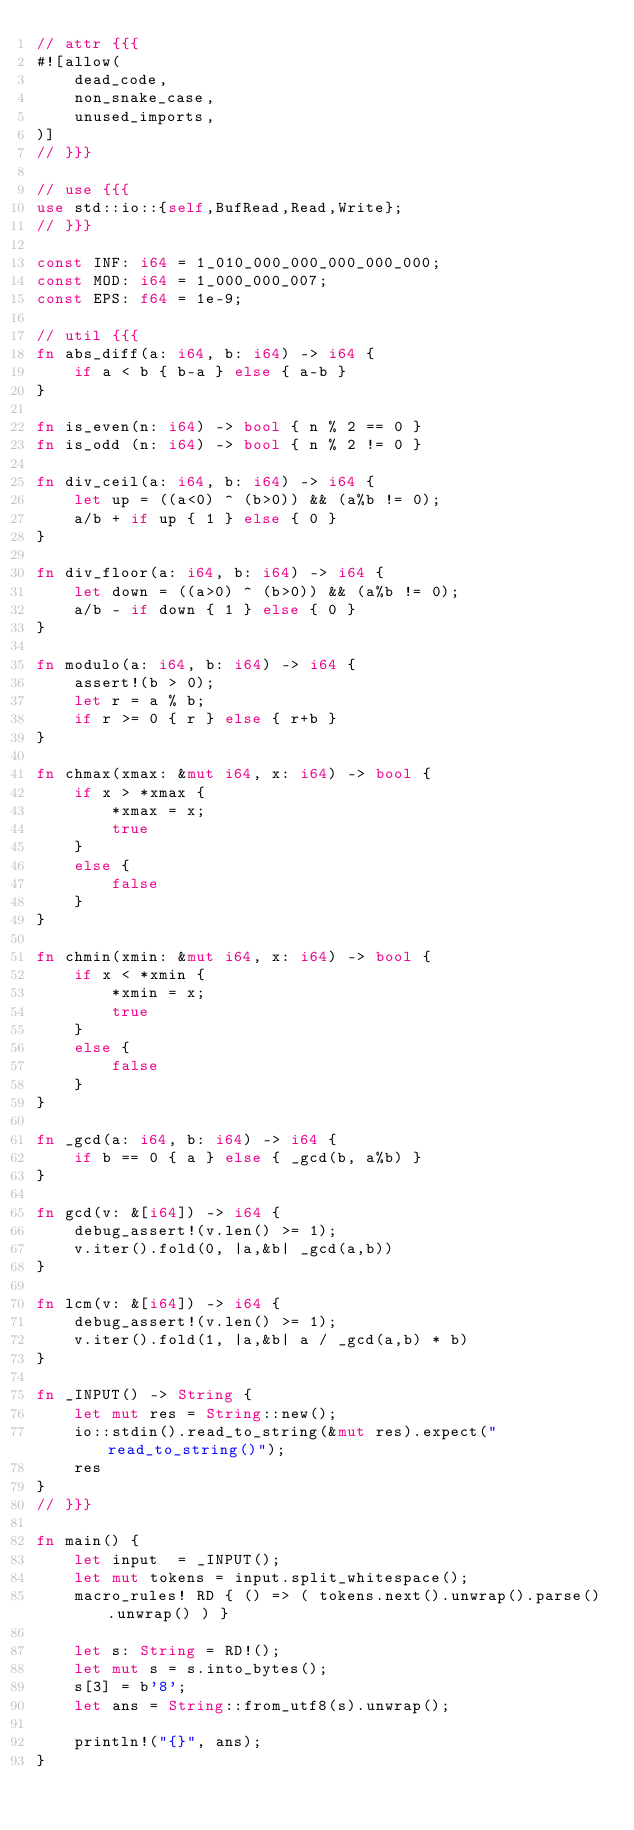Convert code to text. <code><loc_0><loc_0><loc_500><loc_500><_Rust_>// attr {{{
#![allow(
    dead_code,
    non_snake_case,
    unused_imports,
)]
// }}}

// use {{{
use std::io::{self,BufRead,Read,Write};
// }}}

const INF: i64 = 1_010_000_000_000_000_000;
const MOD: i64 = 1_000_000_007;
const EPS: f64 = 1e-9;

// util {{{
fn abs_diff(a: i64, b: i64) -> i64 {
    if a < b { b-a } else { a-b }
}

fn is_even(n: i64) -> bool { n % 2 == 0 }
fn is_odd (n: i64) -> bool { n % 2 != 0 }

fn div_ceil(a: i64, b: i64) -> i64 {
    let up = ((a<0) ^ (b>0)) && (a%b != 0);
    a/b + if up { 1 } else { 0 }
}

fn div_floor(a: i64, b: i64) -> i64 {
    let down = ((a>0) ^ (b>0)) && (a%b != 0);
    a/b - if down { 1 } else { 0 }
}

fn modulo(a: i64, b: i64) -> i64 {
    assert!(b > 0);
    let r = a % b;
    if r >= 0 { r } else { r+b }
}

fn chmax(xmax: &mut i64, x: i64) -> bool {
    if x > *xmax {
        *xmax = x;
        true
    }
    else {
        false
    }
}

fn chmin(xmin: &mut i64, x: i64) -> bool {
    if x < *xmin {
        *xmin = x;
        true
    }
    else {
        false
    }
}

fn _gcd(a: i64, b: i64) -> i64 {
    if b == 0 { a } else { _gcd(b, a%b) }
}

fn gcd(v: &[i64]) -> i64 {
    debug_assert!(v.len() >= 1);
    v.iter().fold(0, |a,&b| _gcd(a,b))
}

fn lcm(v: &[i64]) -> i64 {
    debug_assert!(v.len() >= 1);
    v.iter().fold(1, |a,&b| a / _gcd(a,b) * b)
}

fn _INPUT() -> String {
    let mut res = String::new();
    io::stdin().read_to_string(&mut res).expect("read_to_string()");
    res
}
// }}}

fn main() {
    let input  = _INPUT();
    let mut tokens = input.split_whitespace();
    macro_rules! RD { () => ( tokens.next().unwrap().parse().unwrap() ) }

    let s: String = RD!();
    let mut s = s.into_bytes();
    s[3] = b'8';
    let ans = String::from_utf8(s).unwrap();

    println!("{}", ans);
}
</code> 